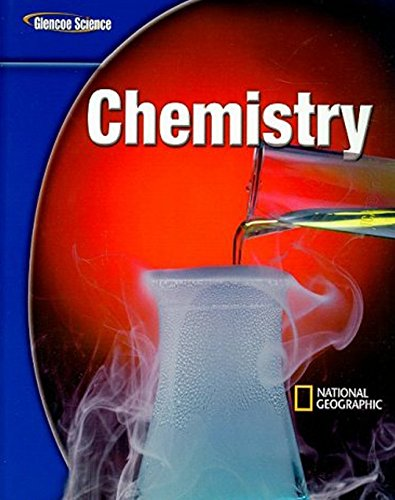How might this book be used in a middle school curriculum? This textbook is likely utilized in middle school science classes to introduce students to fundamental concepts of chemistry including reactions, the periodic table, and the scientific method, fostering a deeper understanding of how everyday chemical processes work. Can you suggest an experiment that might be included in this book? An experiment likely included could be the creation of a simple chemical volcano using baking soda and vinegar to demonstrate an acid-base reaction, showcasing basic chemical reactions in an engaging way. 